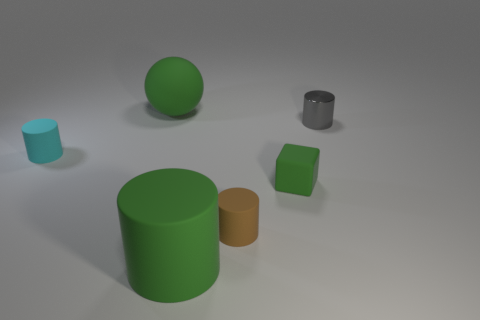Is there any other thing that is the same material as the gray cylinder?
Keep it short and to the point. No. What number of things are either big green matte cylinders or small cylinders that are in front of the small gray cylinder?
Offer a very short reply. 3. There is a rubber cylinder in front of the brown cylinder; is it the same size as the small rubber block?
Offer a very short reply. No. There is a object that is behind the gray shiny thing; what material is it?
Your answer should be compact. Rubber. Are there the same number of tiny brown matte objects on the right side of the brown cylinder and small brown cylinders in front of the big matte cylinder?
Provide a succinct answer. Yes. There is another small rubber object that is the same shape as the small cyan rubber thing; what color is it?
Provide a short and direct response. Brown. Are there any other things that are the same color as the large rubber ball?
Offer a terse response. Yes. How many metal objects are tiny cyan cubes or tiny things?
Ensure brevity in your answer.  1. Do the cube and the large rubber cylinder have the same color?
Your answer should be compact. Yes. Is the number of big objects that are in front of the cyan rubber cylinder greater than the number of red metallic things?
Your answer should be compact. Yes. 